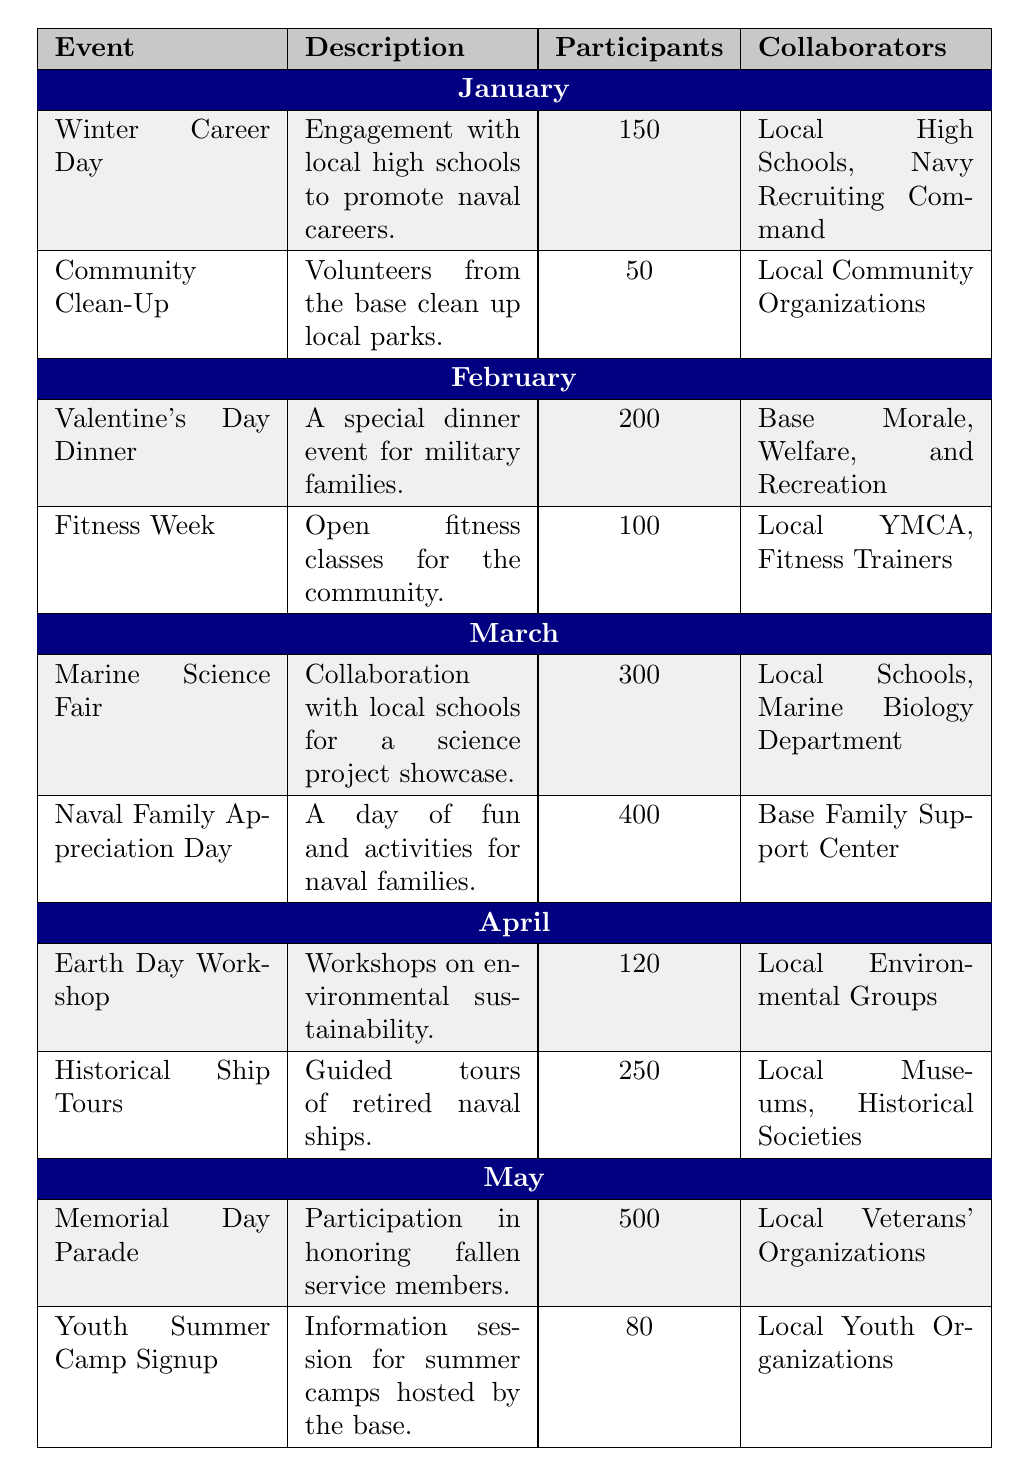What event had the highest number of participants? Looking through the table, the "Memorial Day Parade" in May has 500 participants, which is higher than any other event listed
Answer: Memorial Day Parade How many total participants were there in February? In February, there are two events: "Valentine's Day Dinner" with 200 participants and "Fitness Week" with 100 participants. Adding these together gives a total of 200 + 100 = 300 participants
Answer: 300 Did the Naval Base conduct any community engagement activities in April? Yes, the table lists two events in April: "Earth Day Workshop" and "Historical Ship Tours," confirming that activities occurred
Answer: Yes Which collaborator was involved in the highest number of participants' activities? The "Naval Family Appreciation Day" in March had 400 participants and the "Marine Science Fair" had 300 with collaboration from "Local Schools" and "Marine Biology Department." However, the "Memorial Day Parade" with 500 participants involved "Local Veterans' Organizations," leading to the conclusion that this collaborator reached the highest total of participants
Answer: Local Veterans' Organizations What is the average number of participants across all events in January? In January, the events are "Winter Career Day" with 150 participants and "Community Clean-Up" with 50 participants. The total number of participants is 150 + 50 = 200, and dividing by the 2 events gives 200 / 2 = 100
Answer: 100 Which month had the least number of participants in a single event? Analyzing the table, the "Community Clean-Up" in January had the least number of participants with only 50, lower than the minimum from any other month or event
Answer: January Was there any month where all activities recorded more than 200 participants? Yes, in March, both events, "Marine Science Fair" and "Naval Family Appreciation Day," had more than 200 participants, totaling 300 and 400, respectively
Answer: Yes Which month had the highest engagement activities with environmental themes? April had the "Earth Day Workshop" focused on environmental sustainability and an event related to history, which involved environmental awareness through guided ship tours. Therefore, April is the month with a strong emphasis on environmental activities
Answer: April 